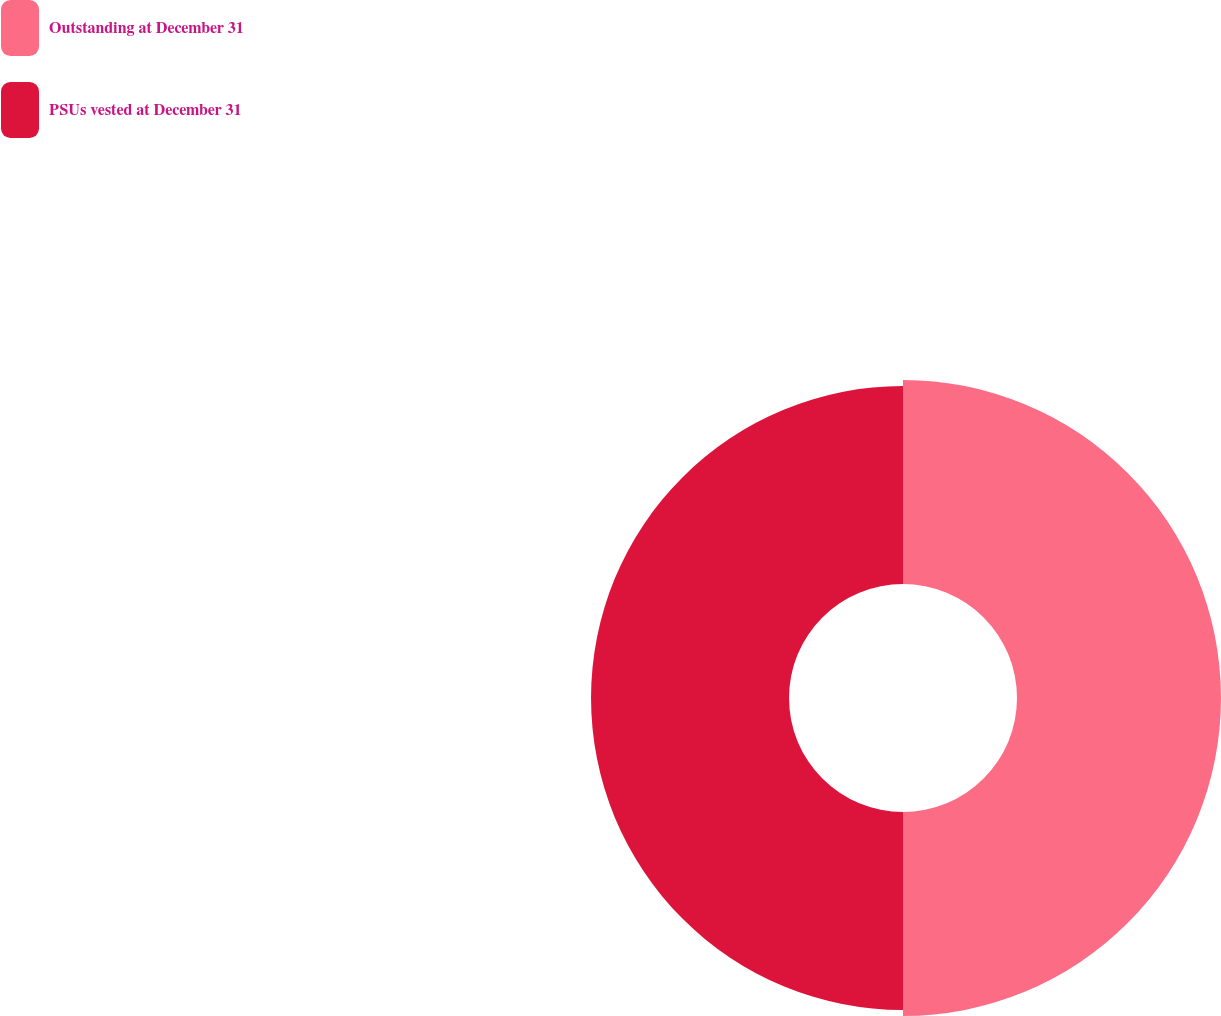Convert chart. <chart><loc_0><loc_0><loc_500><loc_500><pie_chart><fcel>Outstanding at December 31<fcel>PSUs vested at December 31<nl><fcel>50.75%<fcel>49.25%<nl></chart> 